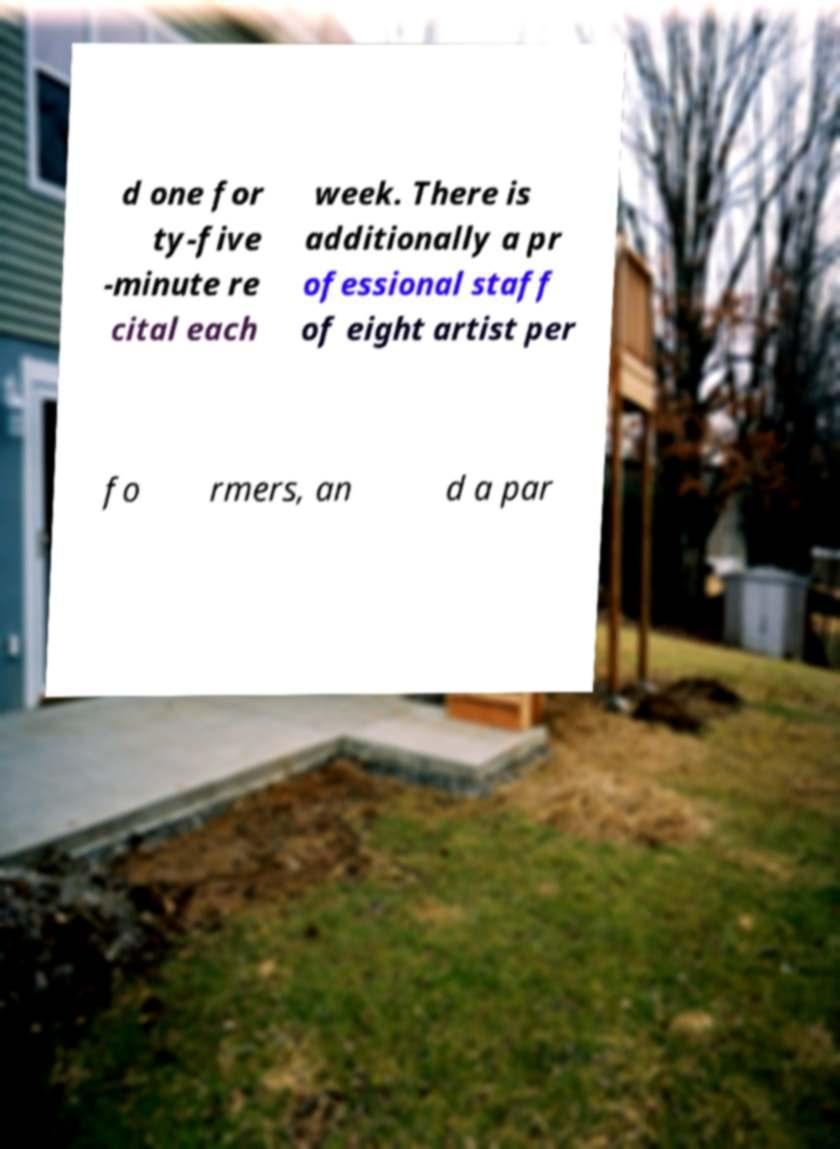I need the written content from this picture converted into text. Can you do that? d one for ty-five -minute re cital each week. There is additionally a pr ofessional staff of eight artist per fo rmers, an d a par 